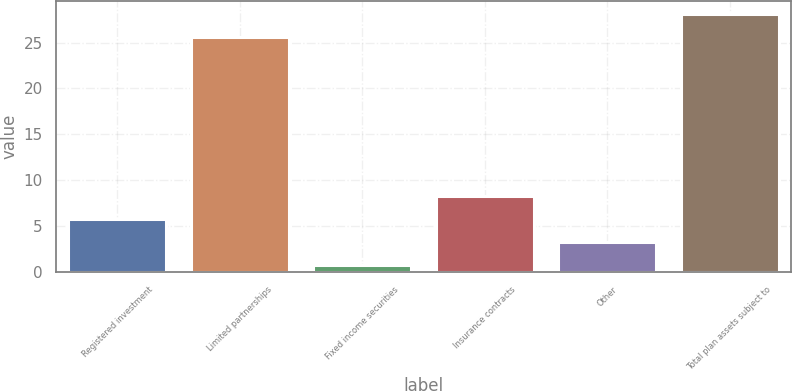Convert chart. <chart><loc_0><loc_0><loc_500><loc_500><bar_chart><fcel>Registered investment<fcel>Limited partnerships<fcel>Fixed income securities<fcel>Insurance contracts<fcel>Other<fcel>Total plan assets subject to<nl><fcel>5.73<fcel>25.6<fcel>0.77<fcel>8.21<fcel>3.25<fcel>28.08<nl></chart> 